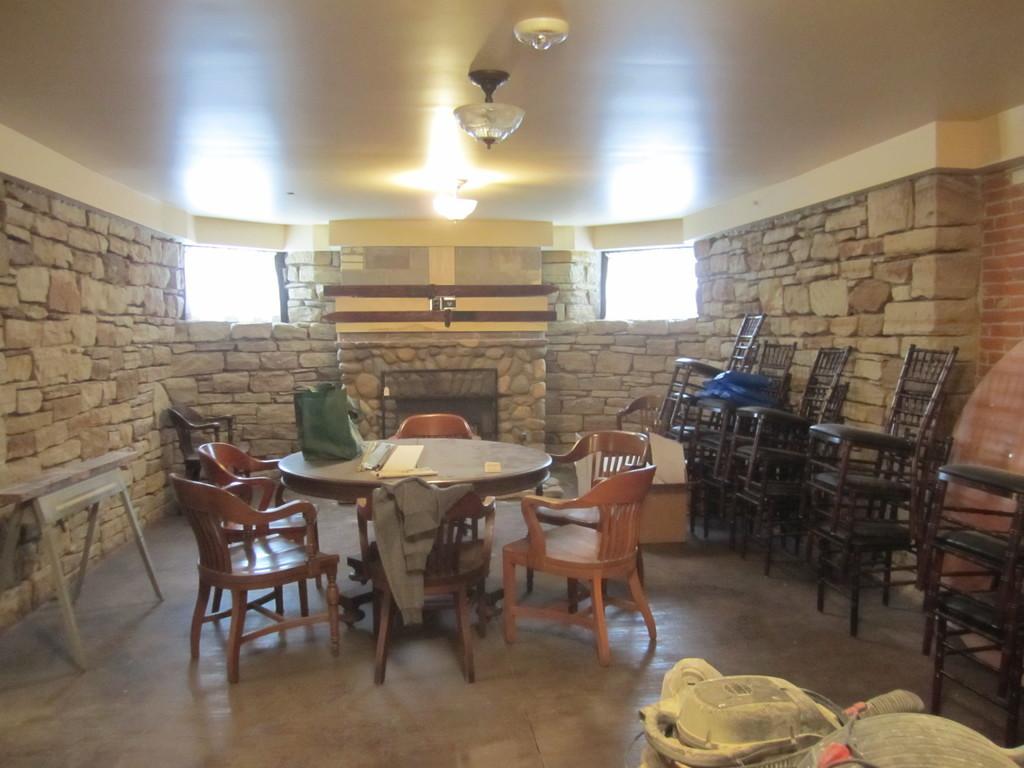Describe this image in one or two sentences. In a room there is a round table, around that table there are some chairs and there are a lot of empty chairs in front of the wall of that room. 